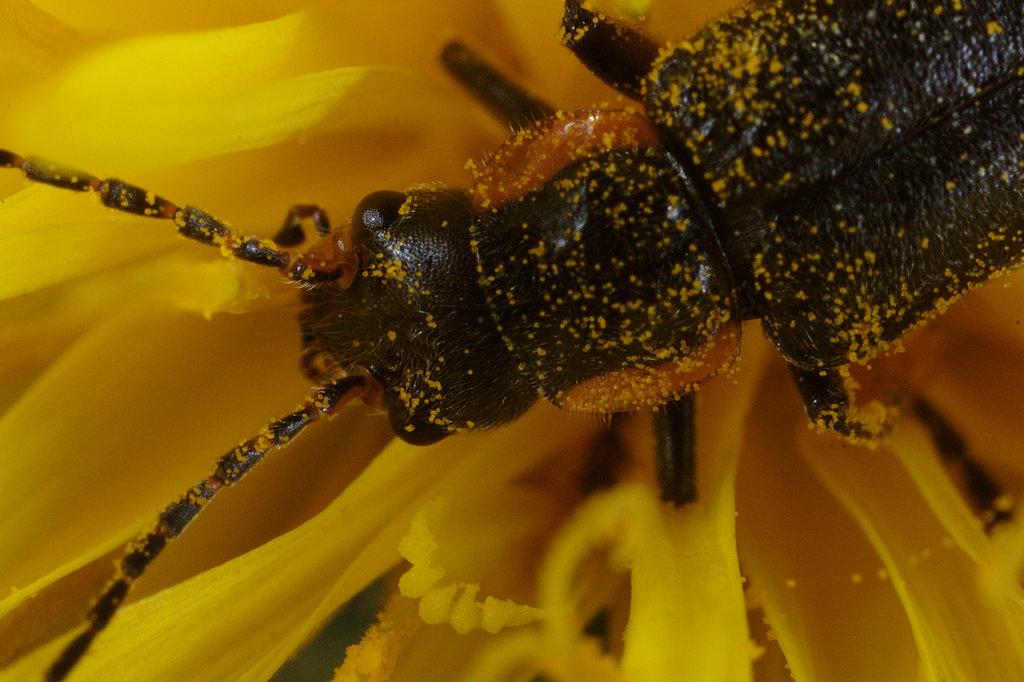What is present on the flower in the image? There is an insect on the flower in the image. What color is the flower that the insect is on? The flower is yellow. How many boats can be seen in the image? There are no boats present in the image. What type of dime is visible on the flower? There is no dime present in the image; it only features an insect on a yellow flower. 